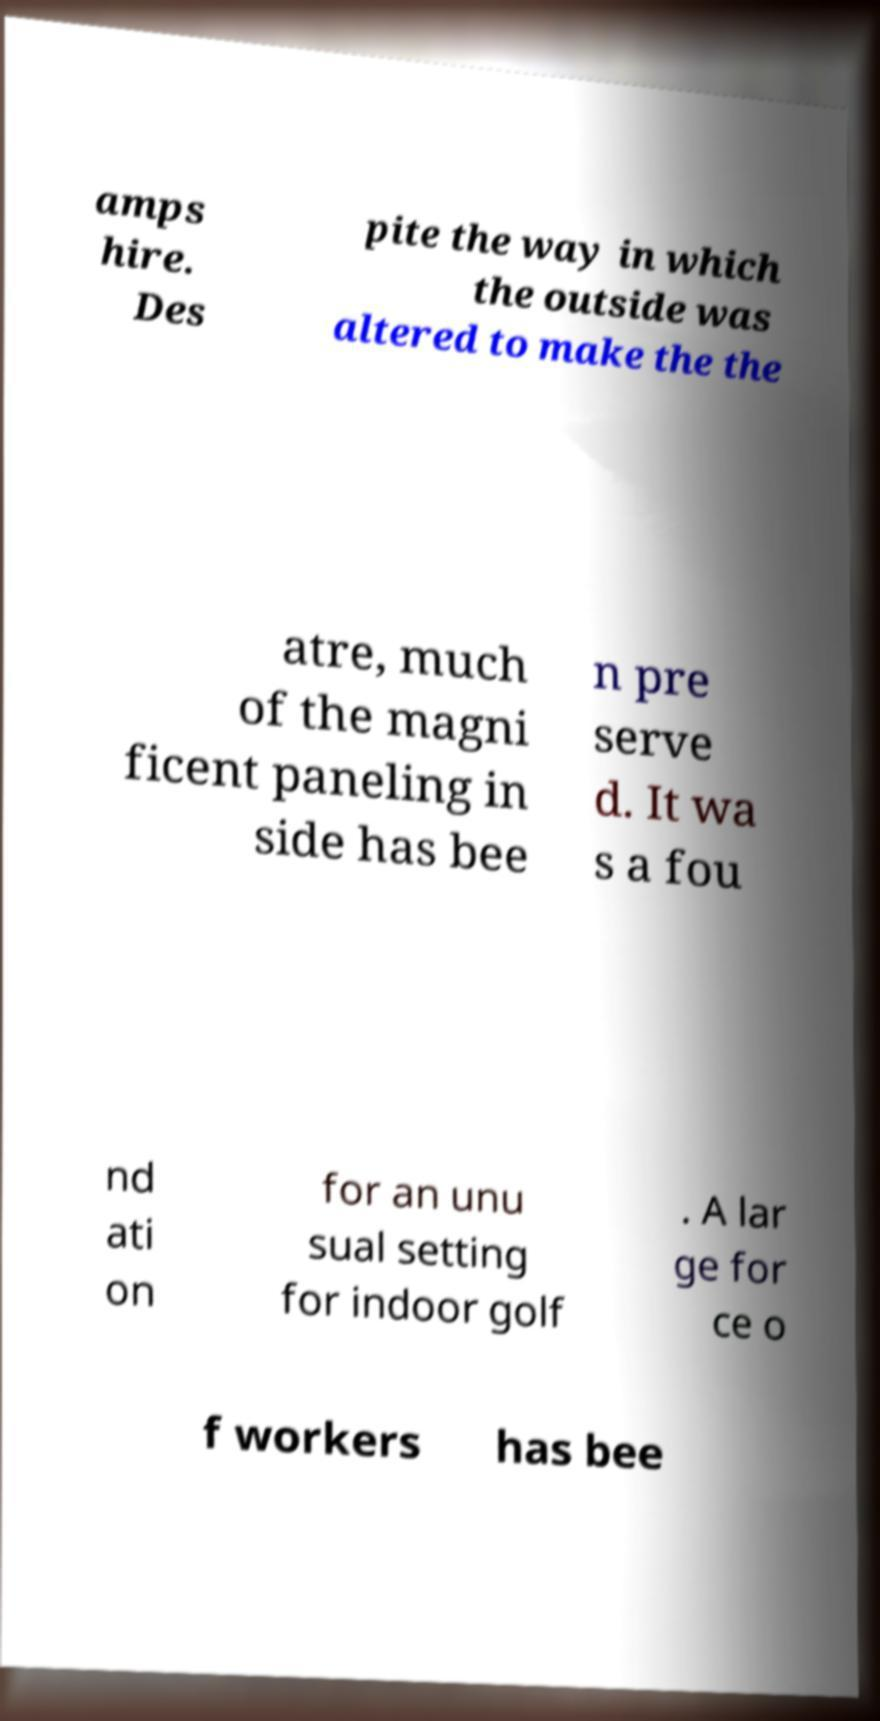Can you read and provide the text displayed in the image?This photo seems to have some interesting text. Can you extract and type it out for me? amps hire. Des pite the way in which the outside was altered to make the the atre, much of the magni ficent paneling in side has bee n pre serve d. It wa s a fou nd ati on for an unu sual setting for indoor golf . A lar ge for ce o f workers has bee 